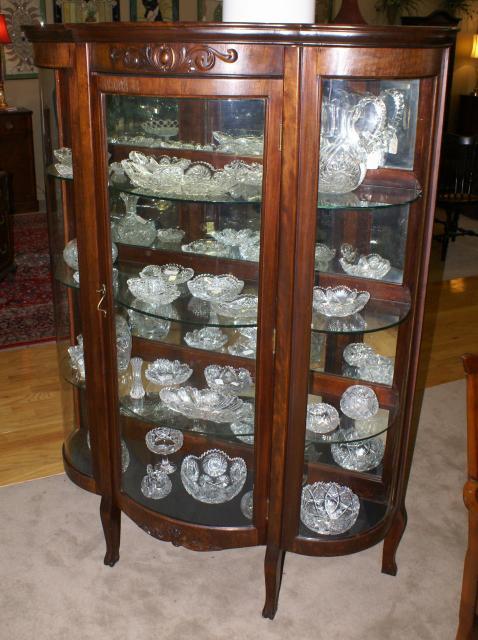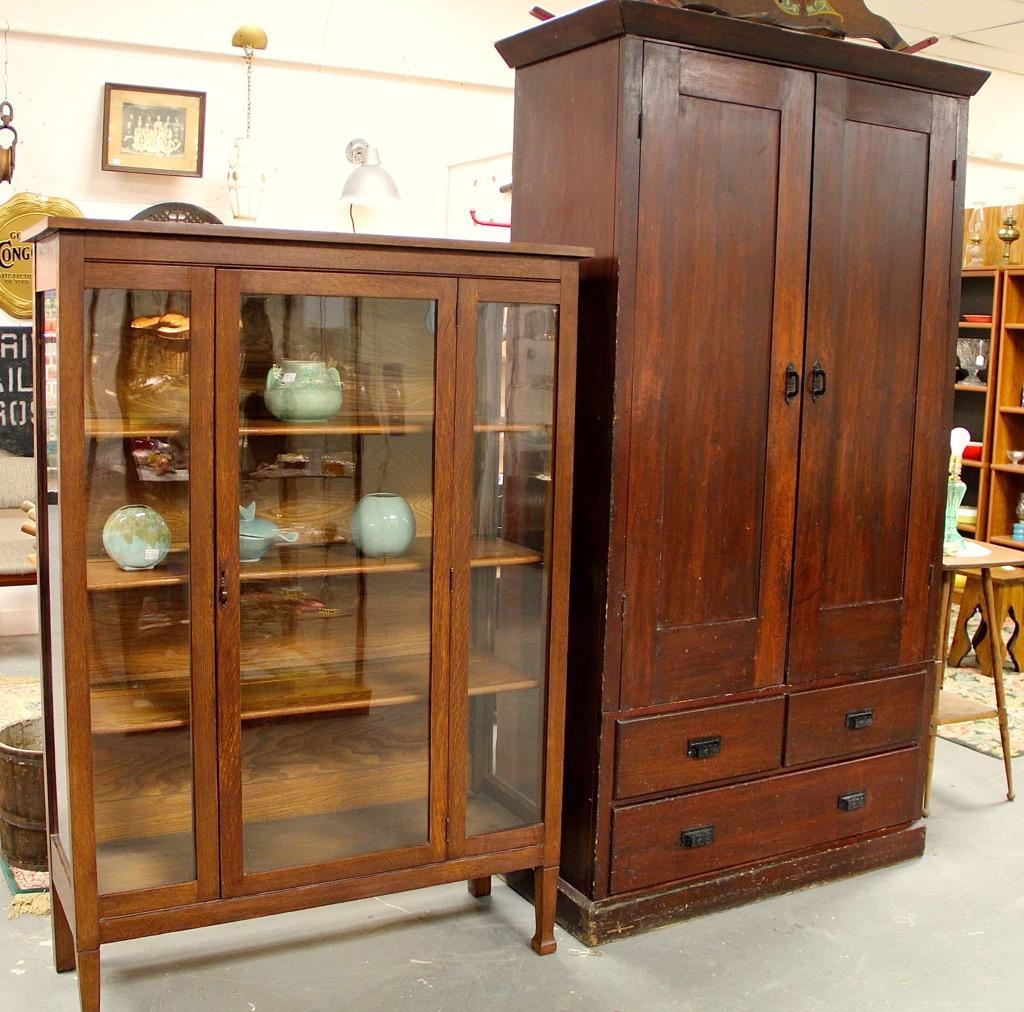The first image is the image on the left, the second image is the image on the right. Given the left and right images, does the statement "All the cabinets have legs." hold true? Answer yes or no. No. 